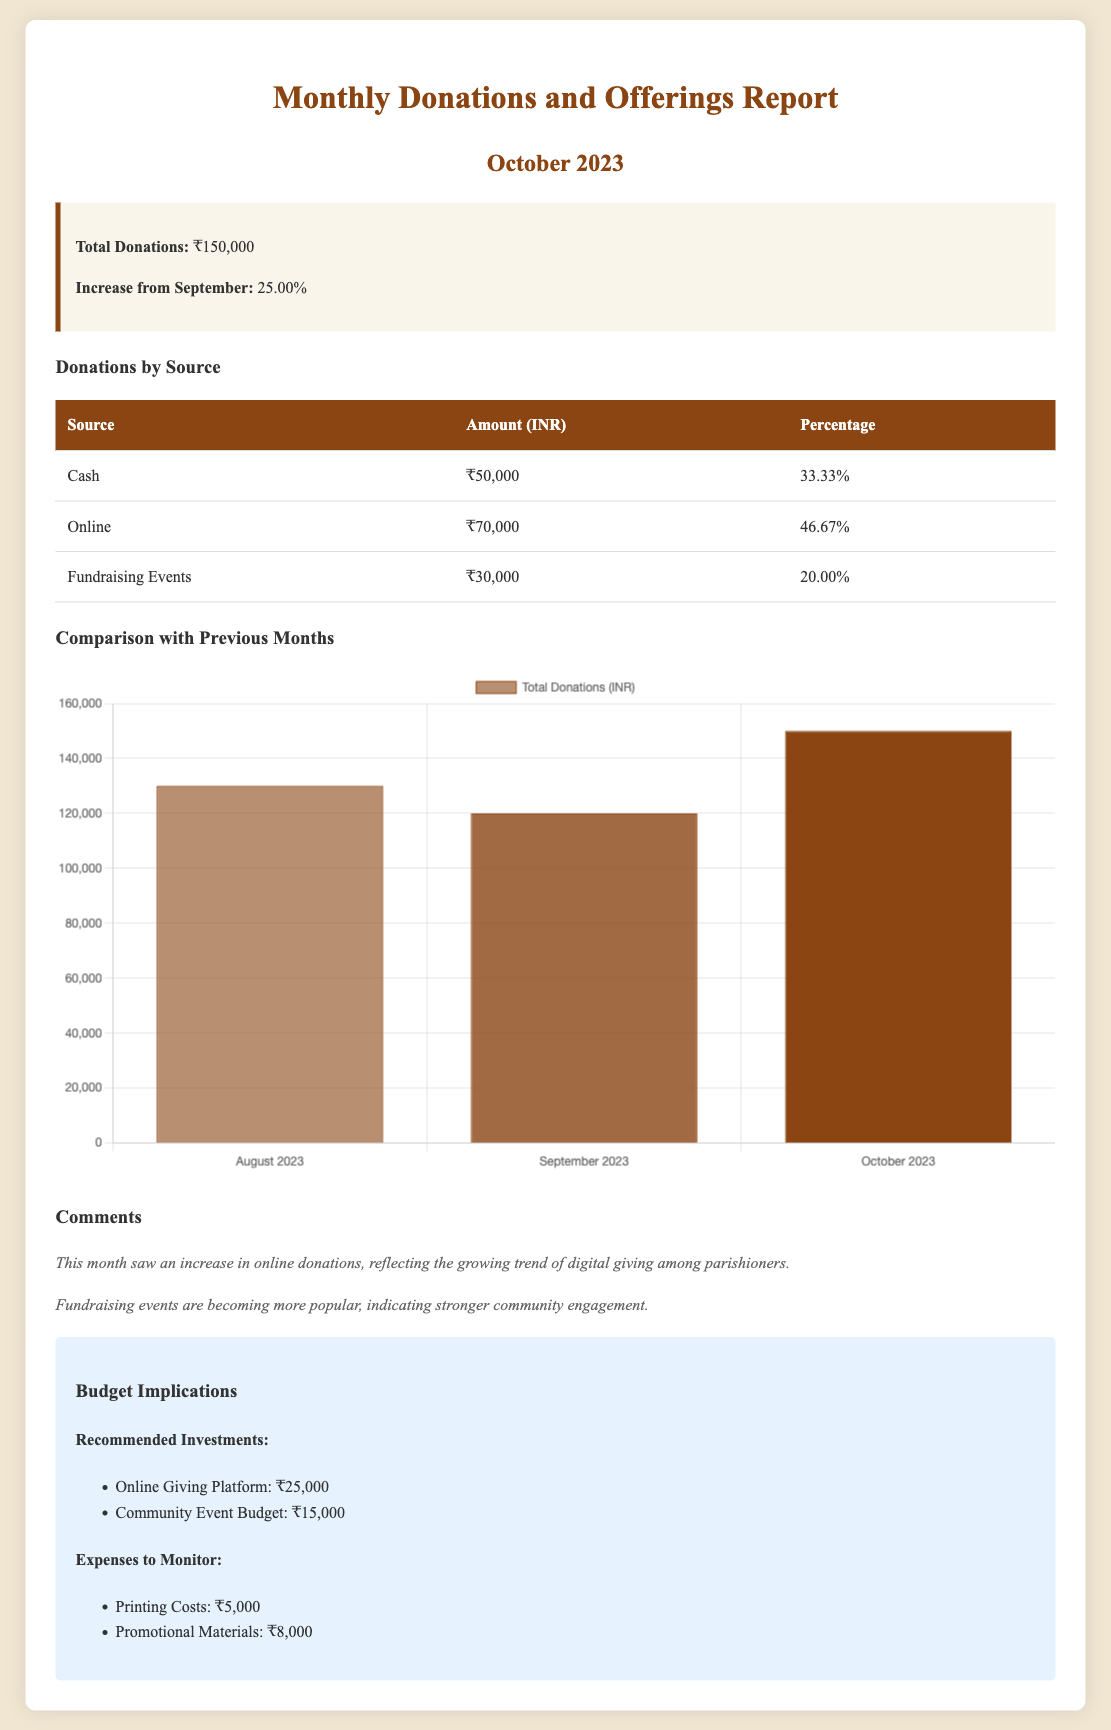What is the total amount of donations collected in October 2023? The total donations for October 2023 is explicitly stated in the summary section of the report.
Answer: ₹150,000 What percentage increase in donations occurred from September to October? The report states a specific increase percentage from September to October, located in the summary section.
Answer: 25.00% How much was collected from online donations? The table provides a detailed breakdown of donations by source, specifically for online donations.
Answer: ₹70,000 What category received the least amount of donations? By comparing the amounts listed for each source, we can identify which category is the smallest.
Answer: Fundraising Events Which month had the highest total donations according to the chart? The comparison chart lists total donations for August, September, and October, allowing us to determine which month had the highest amount.
Answer: October 2023 What is the recommended investment for the online giving platform? The budget section explicitly lists recommended investments, including one for the online giving platform.
Answer: ₹25,000 Which source contributed 20% of the total donations? The table specifies the percentage contribution for each source, allowing us to identify which contributed 20%.
Answer: Fundraising Events What were the expenses listed to monitor? The budget section outlines specific expenses that need to be monitored in bullet points.
Answer: Printing Costs and Promotional Materials 